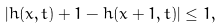<formula> <loc_0><loc_0><loc_500><loc_500>| h ( x , t ) + 1 - h ( x + 1 , t ) | \leq 1 ,</formula> 